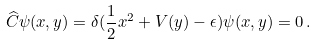Convert formula to latex. <formula><loc_0><loc_0><loc_500><loc_500>\widehat { C } \psi ( x , y ) = \delta ( \frac { 1 } { 2 } x ^ { 2 } + V ( y ) - \epsilon ) \psi ( x , y ) = 0 \, .</formula> 